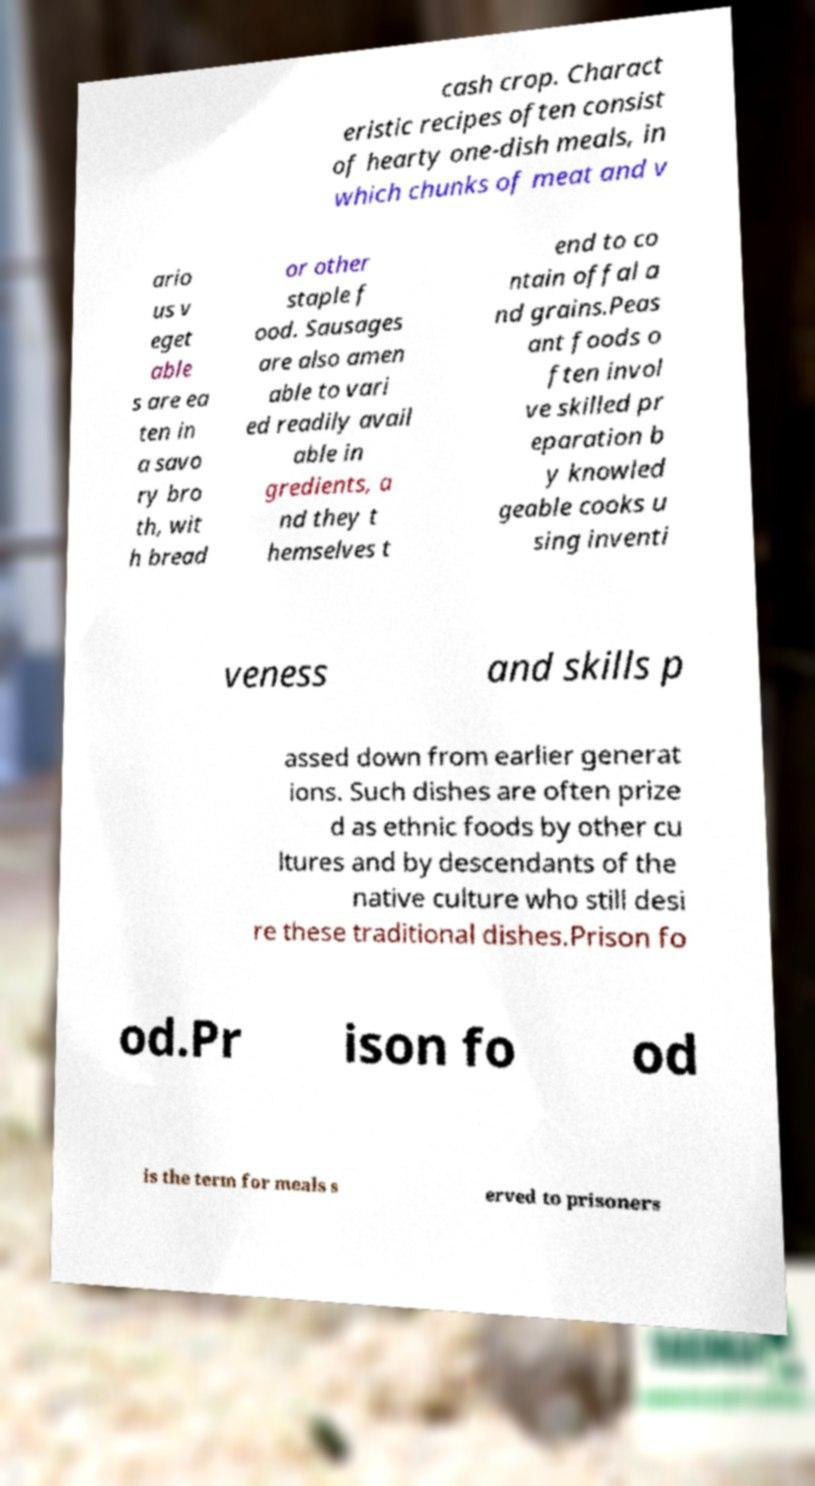There's text embedded in this image that I need extracted. Can you transcribe it verbatim? cash crop. Charact eristic recipes often consist of hearty one-dish meals, in which chunks of meat and v ario us v eget able s are ea ten in a savo ry bro th, wit h bread or other staple f ood. Sausages are also amen able to vari ed readily avail able in gredients, a nd they t hemselves t end to co ntain offal a nd grains.Peas ant foods o ften invol ve skilled pr eparation b y knowled geable cooks u sing inventi veness and skills p assed down from earlier generat ions. Such dishes are often prize d as ethnic foods by other cu ltures and by descendants of the native culture who still desi re these traditional dishes.Prison fo od.Pr ison fo od is the term for meals s erved to prisoners 